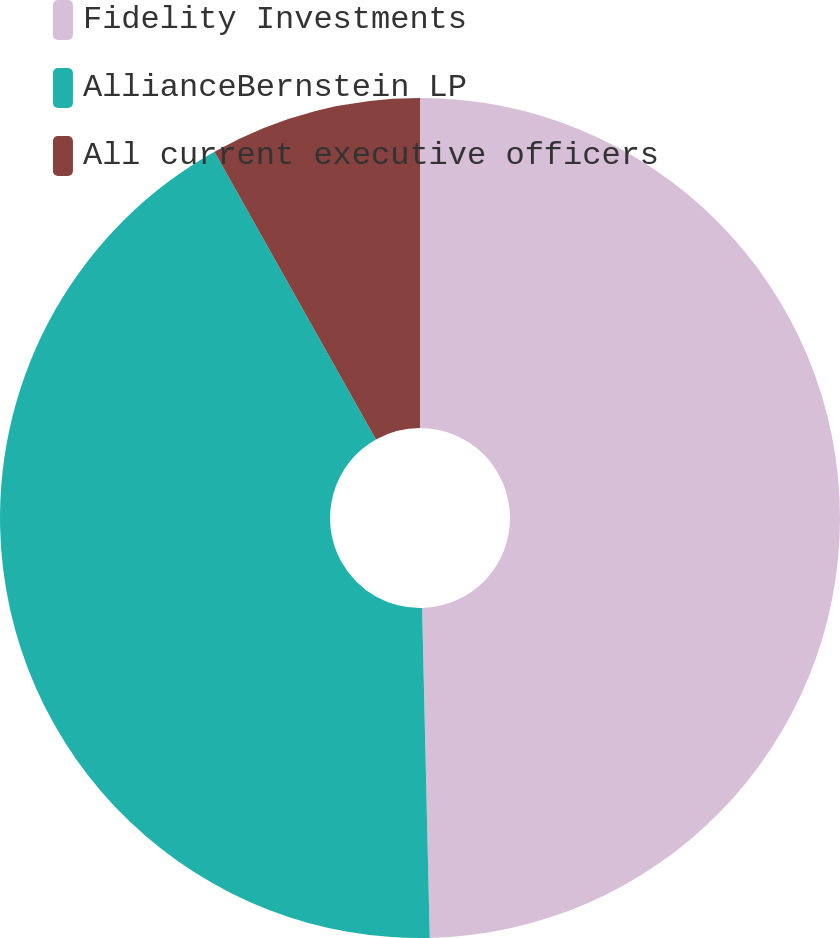Convert chart. <chart><loc_0><loc_0><loc_500><loc_500><pie_chart><fcel>Fidelity Investments<fcel>AllianceBernstein LP<fcel>All current executive officers<nl><fcel>49.63%<fcel>42.23%<fcel>8.14%<nl></chart> 